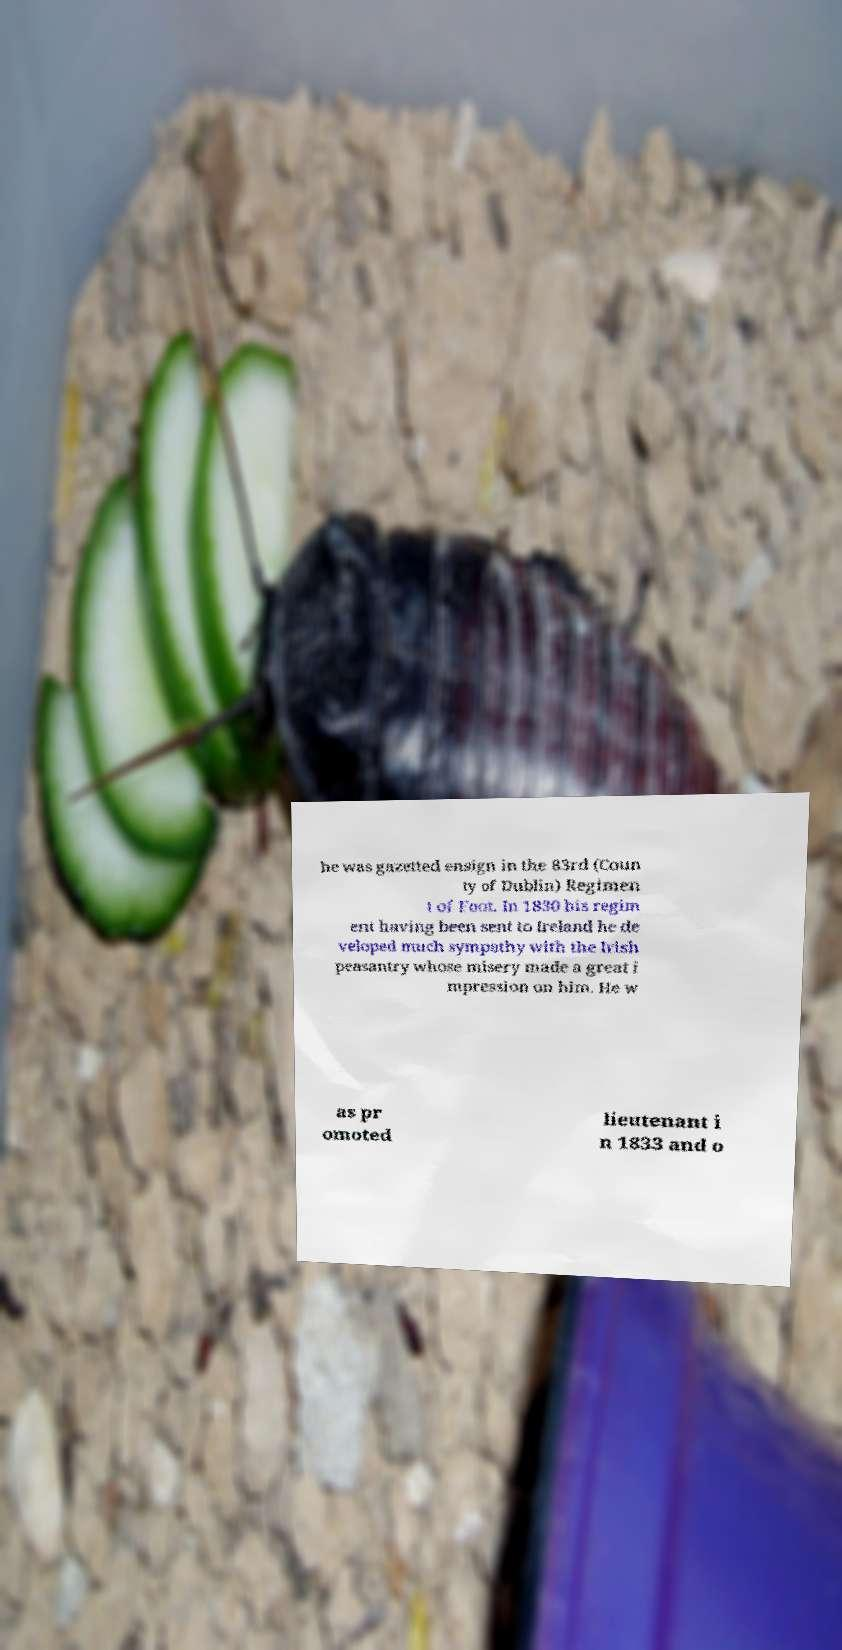For documentation purposes, I need the text within this image transcribed. Could you provide that? he was gazetted ensign in the 83rd (Coun ty of Dublin) Regimen t of Foot. In 1830 his regim ent having been sent to Ireland he de veloped much sympathy with the Irish peasantry whose misery made a great i mpression on him. He w as pr omoted lieutenant i n 1833 and o 